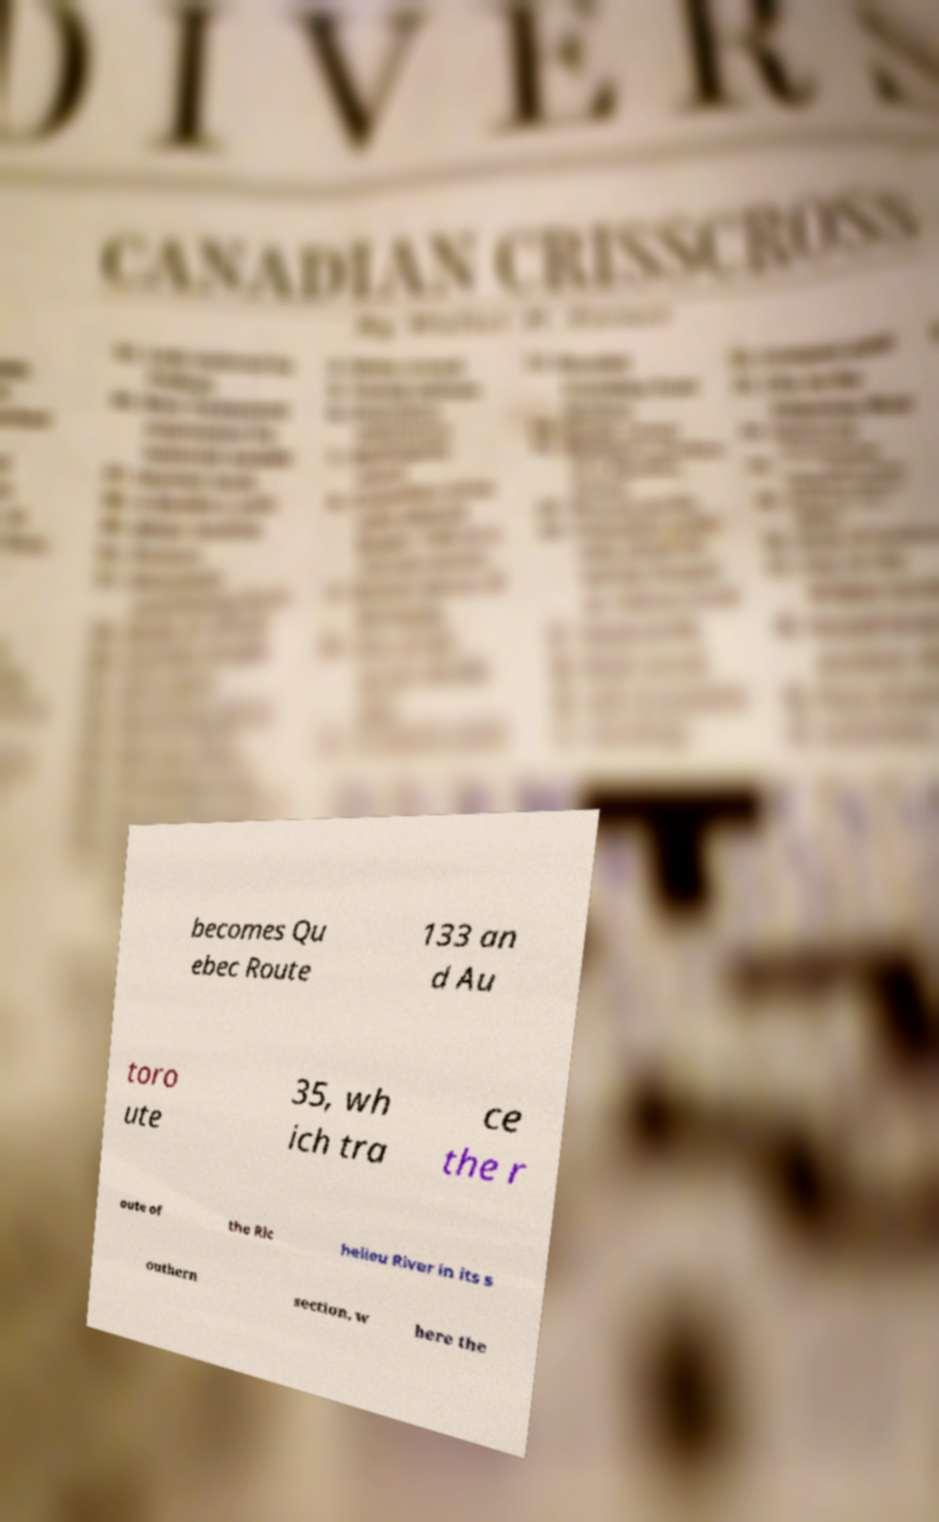Can you accurately transcribe the text from the provided image for me? becomes Qu ebec Route 133 an d Au toro ute 35, wh ich tra ce the r oute of the Ric helieu River in its s outhern section, w here the 